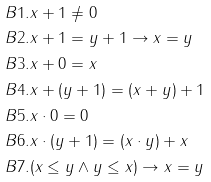<formula> <loc_0><loc_0><loc_500><loc_500>& B 1 . x + 1 \not = 0 \\ & B 2 . x + 1 = y + 1 \rightarrow x = y \\ & B 3 . x + 0 = x \\ & B 4 . x + ( y + 1 ) = ( x + y ) + 1 \\ & B 5 . x \cdot 0 = 0 \\ & B 6 . x \cdot ( y + 1 ) = ( x \cdot y ) + x \\ & B 7 . ( x \leq y \wedge y \leq x ) \rightarrow x = y \\</formula> 